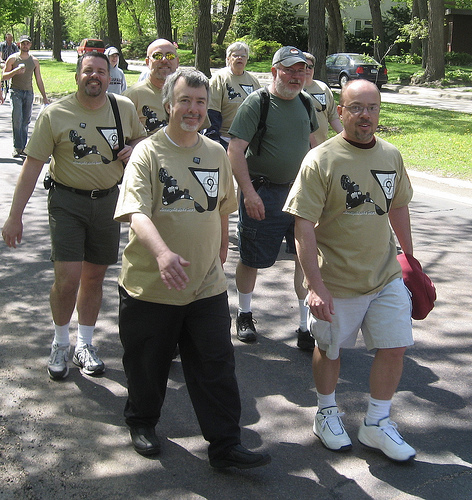<image>
Can you confirm if the man is behind the grass? No. The man is not behind the grass. From this viewpoint, the man appears to be positioned elsewhere in the scene. Is the man next to the man? Yes. The man is positioned adjacent to the man, located nearby in the same general area. 